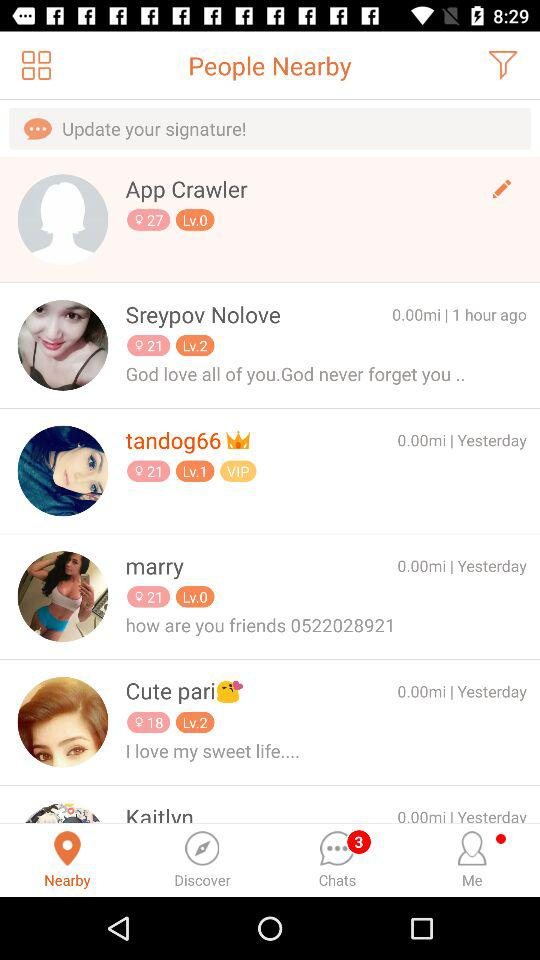What is the age of the app crawler? The age is 27. 